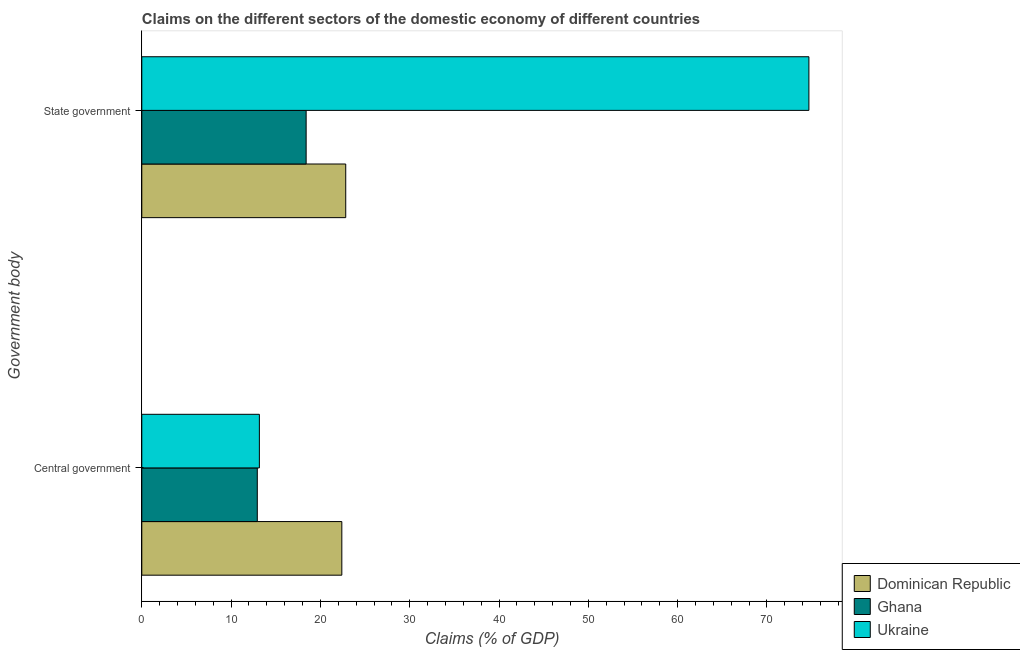How many different coloured bars are there?
Offer a terse response. 3. How many groups of bars are there?
Provide a succinct answer. 2. Are the number of bars per tick equal to the number of legend labels?
Ensure brevity in your answer.  Yes. Are the number of bars on each tick of the Y-axis equal?
Offer a very short reply. Yes. How many bars are there on the 1st tick from the top?
Make the answer very short. 3. What is the label of the 2nd group of bars from the top?
Offer a very short reply. Central government. What is the claims on state government in Dominican Republic?
Your response must be concise. 22.84. Across all countries, what is the maximum claims on central government?
Provide a short and direct response. 22.4. Across all countries, what is the minimum claims on central government?
Your response must be concise. 12.93. In which country was the claims on central government maximum?
Offer a very short reply. Dominican Republic. What is the total claims on state government in the graph?
Make the answer very short. 115.94. What is the difference between the claims on state government in Ghana and that in Dominican Republic?
Your answer should be compact. -4.43. What is the difference between the claims on state government in Ghana and the claims on central government in Dominican Republic?
Keep it short and to the point. -4. What is the average claims on central government per country?
Provide a succinct answer. 16.17. What is the difference between the claims on central government and claims on state government in Dominican Republic?
Your answer should be compact. -0.44. In how many countries, is the claims on central government greater than 4 %?
Offer a very short reply. 3. What is the ratio of the claims on central government in Dominican Republic to that in Ghana?
Provide a succinct answer. 1.73. Is the claims on state government in Dominican Republic less than that in Ukraine?
Your answer should be compact. Yes. In how many countries, is the claims on state government greater than the average claims on state government taken over all countries?
Give a very brief answer. 1. What does the 3rd bar from the bottom in Central government represents?
Provide a short and direct response. Ukraine. How many bars are there?
Your answer should be very brief. 6. How many countries are there in the graph?
Keep it short and to the point. 3. Does the graph contain any zero values?
Your answer should be compact. No. Where does the legend appear in the graph?
Give a very brief answer. Bottom right. How many legend labels are there?
Your response must be concise. 3. What is the title of the graph?
Ensure brevity in your answer.  Claims on the different sectors of the domestic economy of different countries. Does "Faeroe Islands" appear as one of the legend labels in the graph?
Offer a terse response. No. What is the label or title of the X-axis?
Make the answer very short. Claims (% of GDP). What is the label or title of the Y-axis?
Provide a succinct answer. Government body. What is the Claims (% of GDP) of Dominican Republic in Central government?
Ensure brevity in your answer.  22.4. What is the Claims (% of GDP) in Ghana in Central government?
Provide a short and direct response. 12.93. What is the Claims (% of GDP) of Ukraine in Central government?
Offer a very short reply. 13.17. What is the Claims (% of GDP) in Dominican Republic in State government?
Your response must be concise. 22.84. What is the Claims (% of GDP) of Ghana in State government?
Offer a very short reply. 18.4. What is the Claims (% of GDP) of Ukraine in State government?
Keep it short and to the point. 74.7. Across all Government body, what is the maximum Claims (% of GDP) in Dominican Republic?
Offer a very short reply. 22.84. Across all Government body, what is the maximum Claims (% of GDP) of Ghana?
Provide a short and direct response. 18.4. Across all Government body, what is the maximum Claims (% of GDP) in Ukraine?
Make the answer very short. 74.7. Across all Government body, what is the minimum Claims (% of GDP) of Dominican Republic?
Provide a short and direct response. 22.4. Across all Government body, what is the minimum Claims (% of GDP) of Ghana?
Provide a short and direct response. 12.93. Across all Government body, what is the minimum Claims (% of GDP) of Ukraine?
Your answer should be very brief. 13.17. What is the total Claims (% of GDP) in Dominican Republic in the graph?
Provide a succinct answer. 45.23. What is the total Claims (% of GDP) of Ghana in the graph?
Give a very brief answer. 31.34. What is the total Claims (% of GDP) of Ukraine in the graph?
Offer a terse response. 87.87. What is the difference between the Claims (% of GDP) of Dominican Republic in Central government and that in State government?
Ensure brevity in your answer.  -0.44. What is the difference between the Claims (% of GDP) in Ghana in Central government and that in State government?
Give a very brief answer. -5.47. What is the difference between the Claims (% of GDP) in Ukraine in Central government and that in State government?
Give a very brief answer. -61.53. What is the difference between the Claims (% of GDP) of Dominican Republic in Central government and the Claims (% of GDP) of Ghana in State government?
Your response must be concise. 4. What is the difference between the Claims (% of GDP) of Dominican Republic in Central government and the Claims (% of GDP) of Ukraine in State government?
Keep it short and to the point. -52.3. What is the difference between the Claims (% of GDP) in Ghana in Central government and the Claims (% of GDP) in Ukraine in State government?
Your answer should be very brief. -61.77. What is the average Claims (% of GDP) in Dominican Republic per Government body?
Your answer should be compact. 22.62. What is the average Claims (% of GDP) of Ghana per Government body?
Ensure brevity in your answer.  15.67. What is the average Claims (% of GDP) of Ukraine per Government body?
Your answer should be very brief. 43.93. What is the difference between the Claims (% of GDP) in Dominican Republic and Claims (% of GDP) in Ghana in Central government?
Provide a succinct answer. 9.47. What is the difference between the Claims (% of GDP) in Dominican Republic and Claims (% of GDP) in Ukraine in Central government?
Your answer should be compact. 9.23. What is the difference between the Claims (% of GDP) in Ghana and Claims (% of GDP) in Ukraine in Central government?
Provide a short and direct response. -0.23. What is the difference between the Claims (% of GDP) in Dominican Republic and Claims (% of GDP) in Ghana in State government?
Offer a very short reply. 4.43. What is the difference between the Claims (% of GDP) of Dominican Republic and Claims (% of GDP) of Ukraine in State government?
Provide a short and direct response. -51.86. What is the difference between the Claims (% of GDP) in Ghana and Claims (% of GDP) in Ukraine in State government?
Offer a very short reply. -56.3. What is the ratio of the Claims (% of GDP) in Dominican Republic in Central government to that in State government?
Provide a succinct answer. 0.98. What is the ratio of the Claims (% of GDP) of Ghana in Central government to that in State government?
Offer a very short reply. 0.7. What is the ratio of the Claims (% of GDP) of Ukraine in Central government to that in State government?
Provide a short and direct response. 0.18. What is the difference between the highest and the second highest Claims (% of GDP) of Dominican Republic?
Provide a short and direct response. 0.44. What is the difference between the highest and the second highest Claims (% of GDP) of Ghana?
Offer a very short reply. 5.47. What is the difference between the highest and the second highest Claims (% of GDP) of Ukraine?
Give a very brief answer. 61.53. What is the difference between the highest and the lowest Claims (% of GDP) of Dominican Republic?
Provide a short and direct response. 0.44. What is the difference between the highest and the lowest Claims (% of GDP) in Ghana?
Offer a very short reply. 5.47. What is the difference between the highest and the lowest Claims (% of GDP) in Ukraine?
Your answer should be compact. 61.53. 